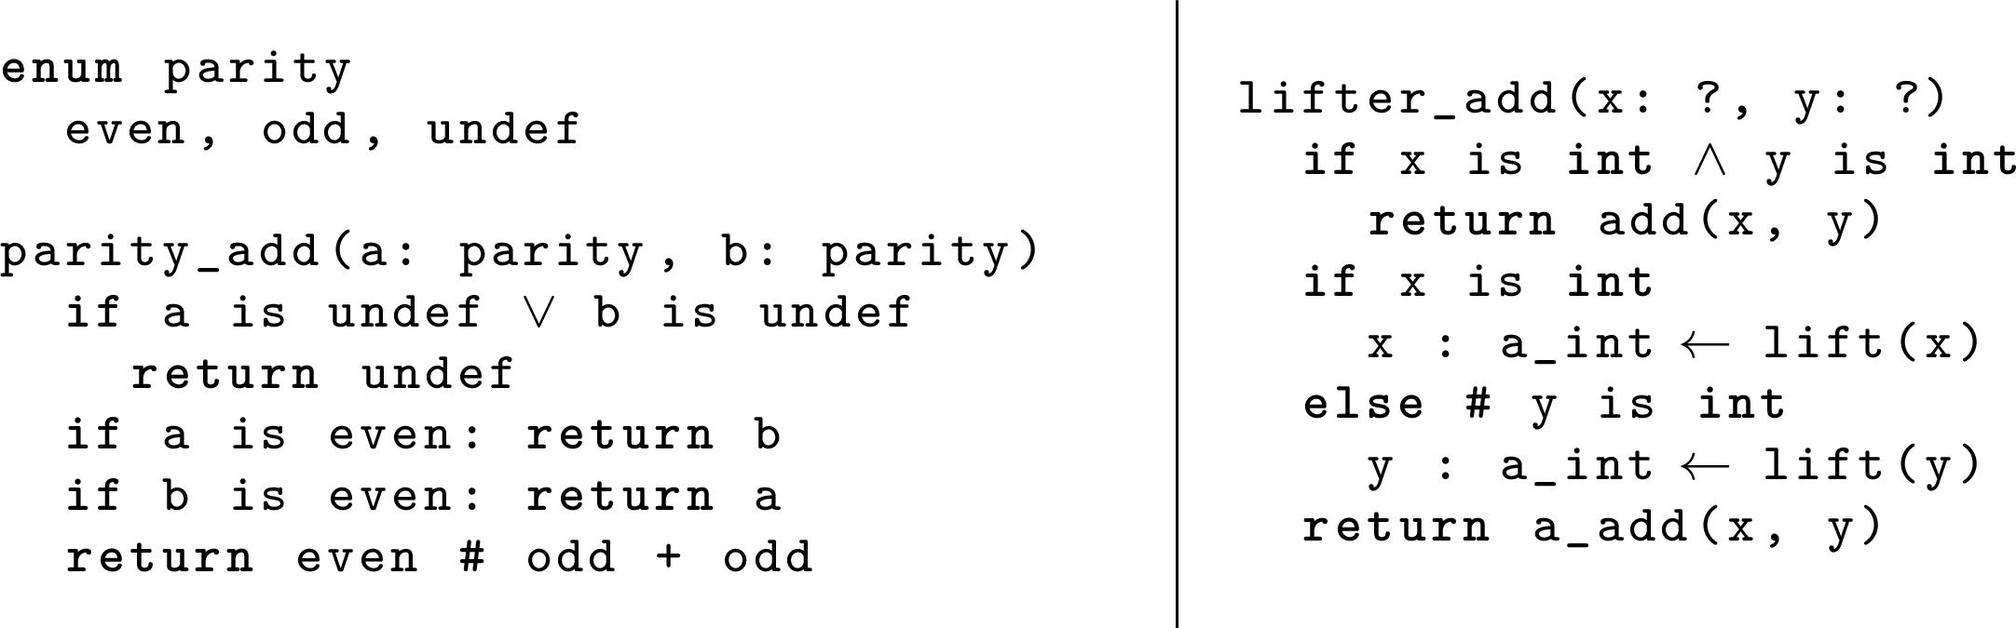In the `parity_add` function, if `a` is `even` and `b` is `undef`, what will the function return? A. even B. odd C. undef D. b In accordance with the `parity_add` function's logic depicted in the image, which outlines a conditional check for undefined (`undef`) inputs, the output will be `undef` whenever either input parameter, `a` or `b`, is in an undefined state. Specifically, if `a` is categorized as `even` and `b` remains `undef`, the function promptly returns `undef`, without further computation, ensuring the integrity of output amidst undefined inputs. 